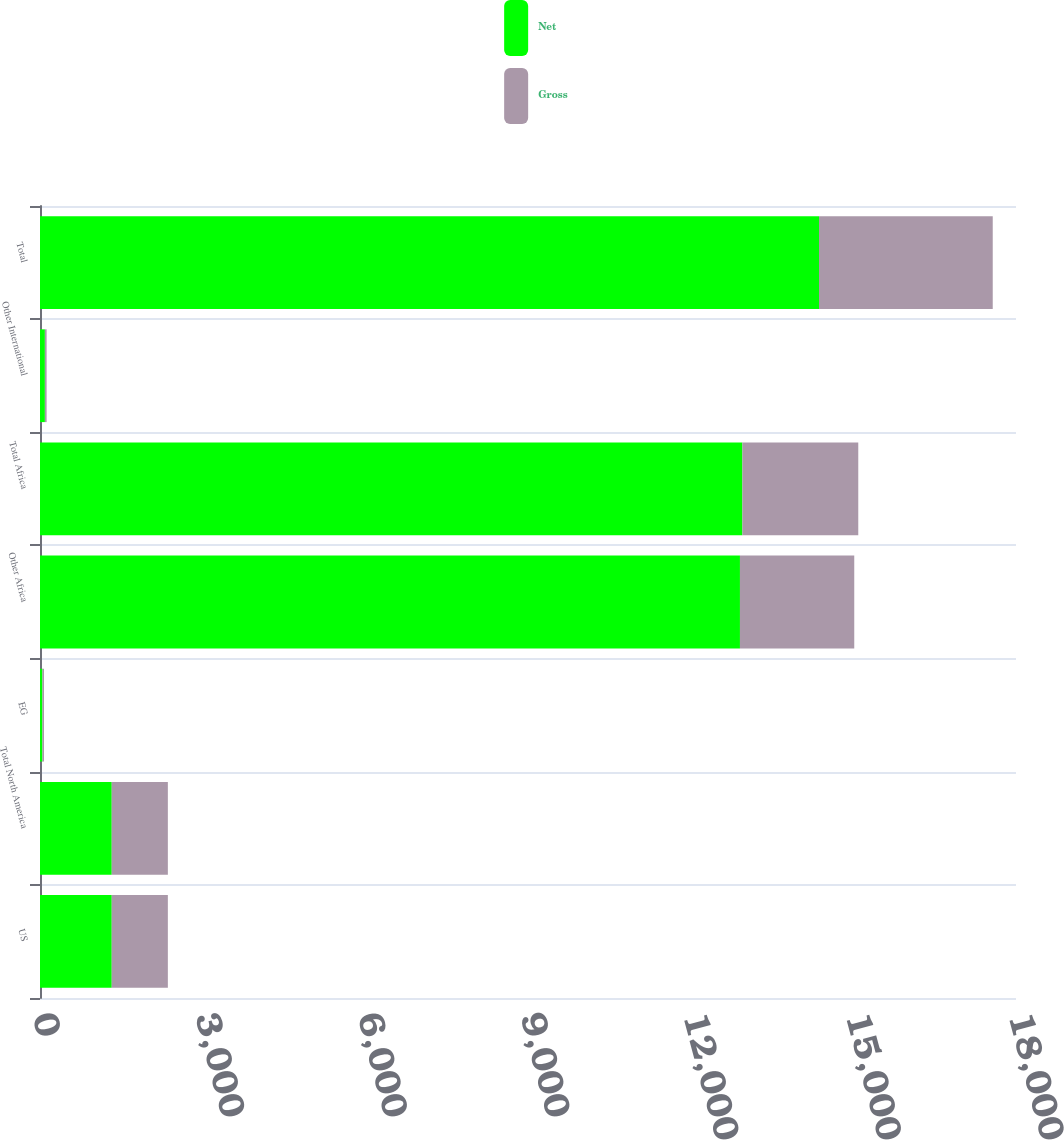Convert chart. <chart><loc_0><loc_0><loc_500><loc_500><stacked_bar_chart><ecel><fcel>US<fcel>Total North America<fcel>EG<fcel>Other Africa<fcel>Total Africa<fcel>Other International<fcel>Total<nl><fcel>Net<fcel>1323<fcel>1323<fcel>45<fcel>12909<fcel>12954<fcel>90<fcel>14367<nl><fcel>Gross<fcel>1035<fcel>1035<fcel>29<fcel>2108<fcel>2137<fcel>32<fcel>3204<nl></chart> 